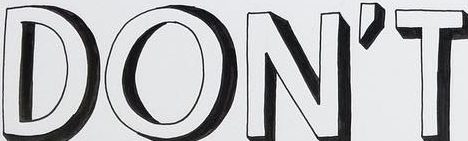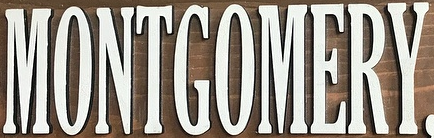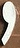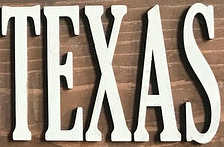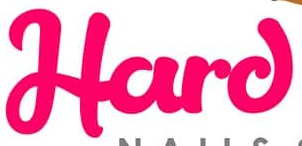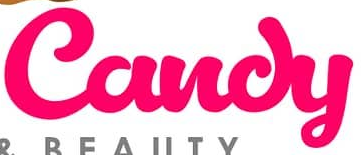What text appears in these images from left to right, separated by a semicolon? DON'T; MONTGOMERY; ,; TEXAS; Hard; Candy 